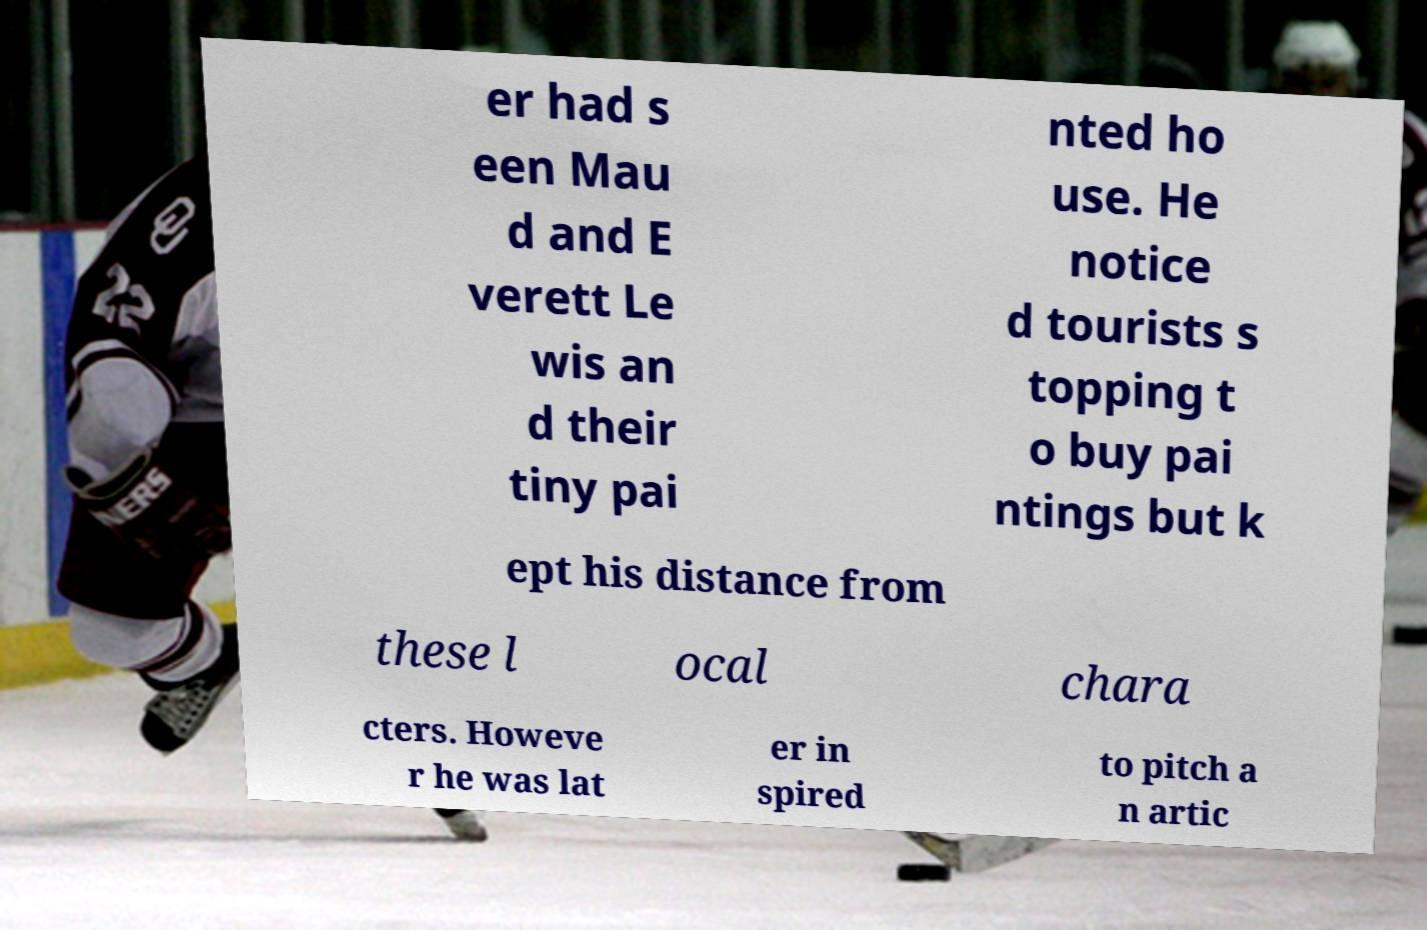I need the written content from this picture converted into text. Can you do that? er had s een Mau d and E verett Le wis an d their tiny pai nted ho use. He notice d tourists s topping t o buy pai ntings but k ept his distance from these l ocal chara cters. Howeve r he was lat er in spired to pitch a n artic 